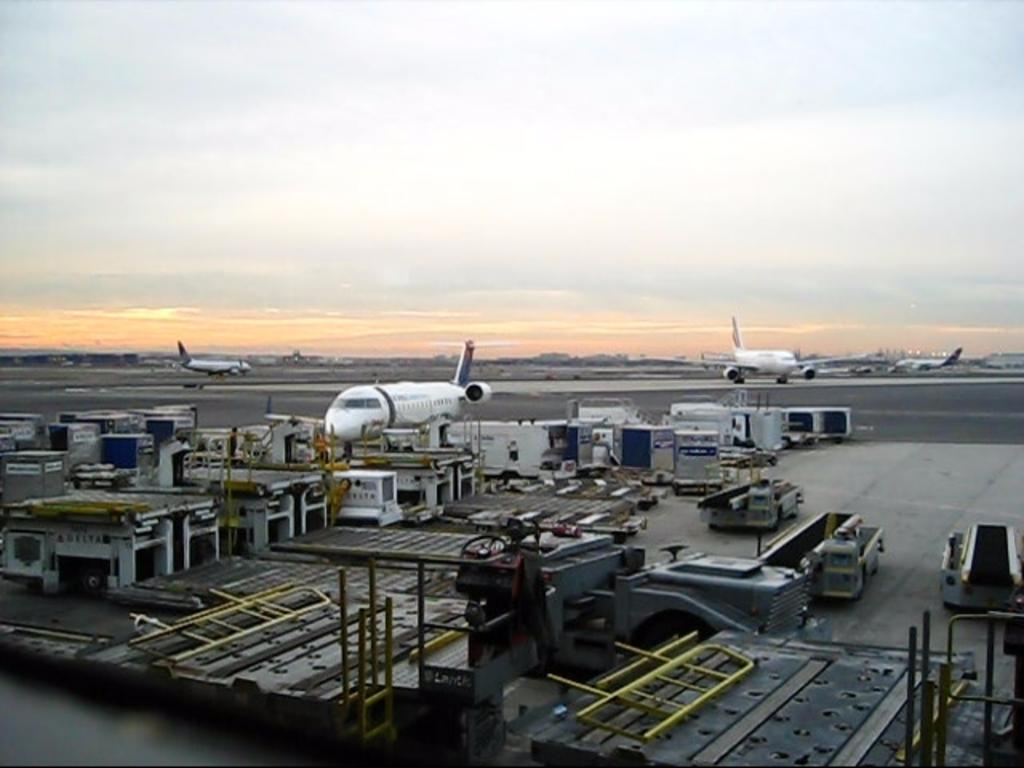What type of transportation is depicted in the image? There are aeroplanes and vehicles in the image. What other objects can be seen in the image? There are objects, rods, and machines in the image. What is visible in the background of the image? The sky is visible in the background of the image. How would you describe the weather based on the sky in the image? The sky appears to be cloudy in the image. What type of quince is being used to play music in the image? There is no quince or music present in the image. How many yams are visible in the image? There are no yams present in the image. 